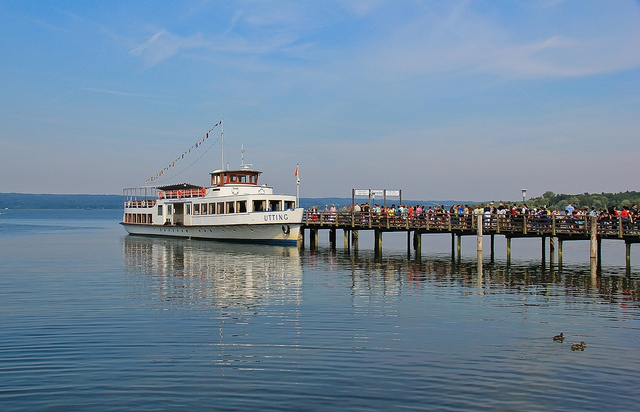Describe the objects in this image and their specific colors. I can see boat in gray, black, lightgray, and darkgray tones, people in gray, black, and maroon tones, people in gray, black, maroon, and darkgray tones, people in gray, black, and maroon tones, and people in gray, black, and maroon tones in this image. 